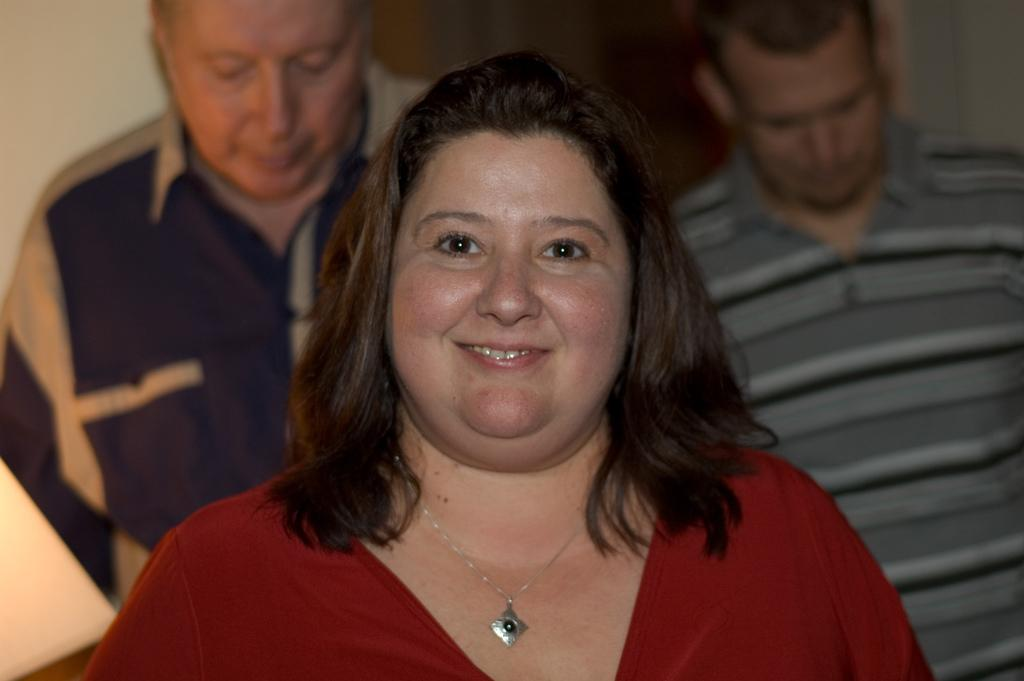Who is the main subject in the image? There is a lady in the center of the image. What is the lady wearing? The lady is wearing a red dress. Can you describe the background of the image? There are two persons in the background of the image. What is the purpose of the stream in the image? There is no stream present in the image. 